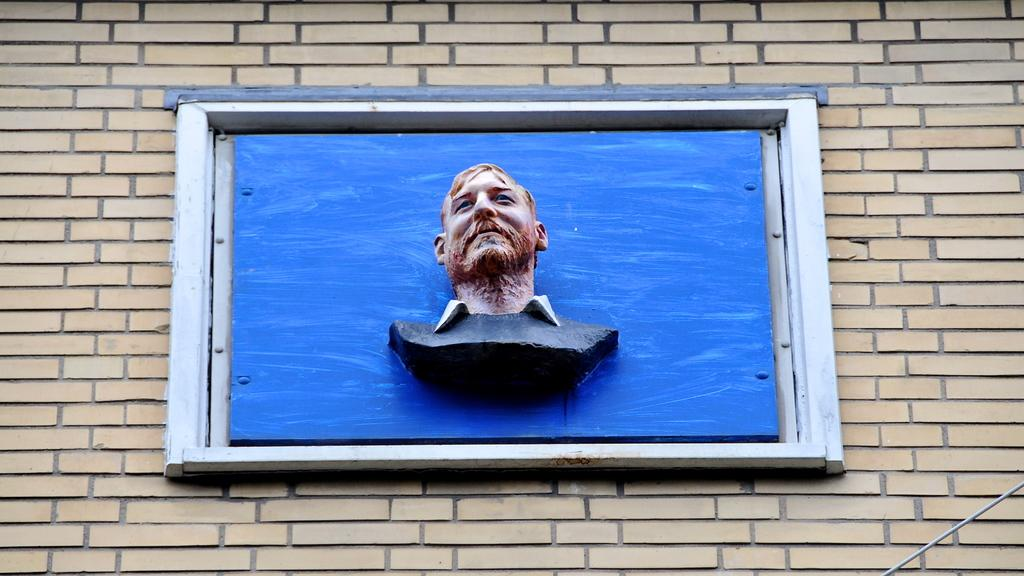What is the main subject of the image? There is a man sculpture in the image. Where is the man sculpture located? The man sculpture is on a window. What is the window situated over? The window is over a wall. What type of brake can be seen on the man sculpture in the image? There is no brake present on the man sculpture in the image. 